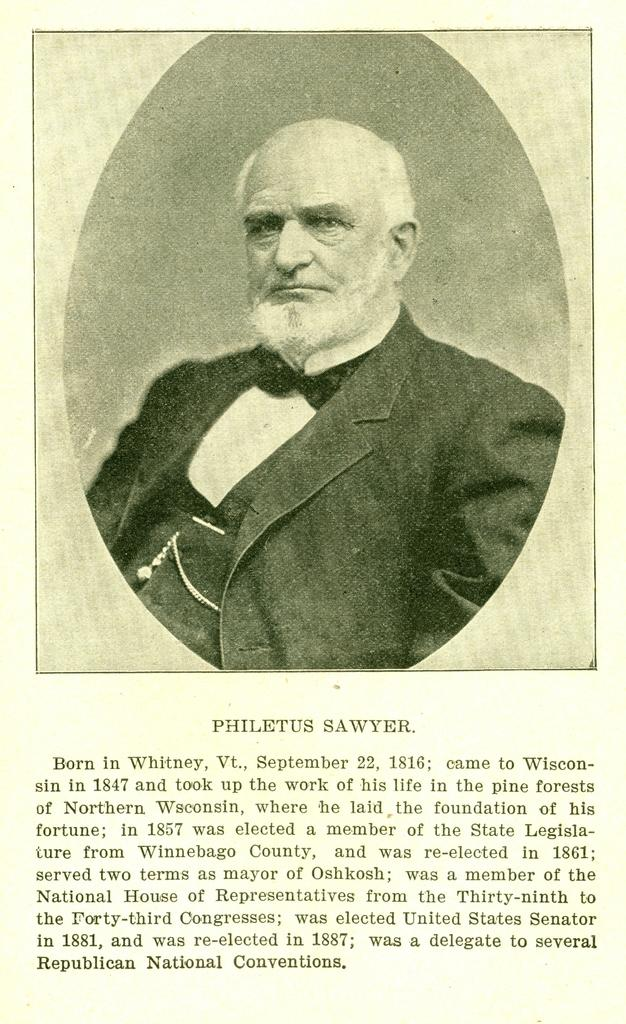What type of visual is depicted in the image? The image is a poster. Who is featured in the poster? There is a woman in the poster. What is the woman wearing? The woman is wearing a blazer. Where can additional information be found on the poster? There is information at the bottom portion of the poster. What type of noise can be heard coming from the clock in the image? There is no clock present in the image, so it is not possible to determine what type of noise might be heard. 